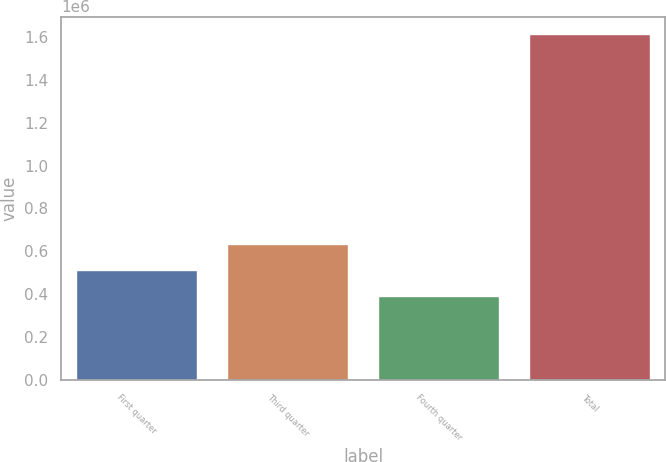Convert chart to OTSL. <chart><loc_0><loc_0><loc_500><loc_500><bar_chart><fcel>First quarter<fcel>Third quarter<fcel>Fourth quarter<fcel>Total<nl><fcel>513191<fcel>635562<fcel>390821<fcel>1.61452e+06<nl></chart> 